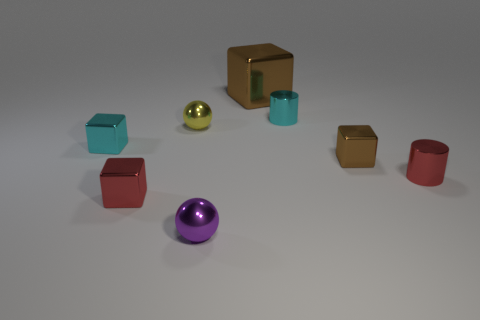Are there fewer tiny metal cubes to the left of the small cyan metal block than big purple blocks?
Provide a short and direct response. No. Does the small yellow object have the same shape as the big brown metallic thing?
Give a very brief answer. No. What is the size of the purple object that is made of the same material as the yellow ball?
Keep it short and to the point. Small. Is the number of cyan objects less than the number of small yellow balls?
Provide a succinct answer. No. What number of small things are metal objects or brown blocks?
Provide a succinct answer. 7. What number of small objects are on the left side of the big brown metallic cube and behind the purple metallic ball?
Ensure brevity in your answer.  3. Is the number of big yellow matte spheres greater than the number of brown objects?
Offer a terse response. No. What number of other things are the same shape as the tiny brown shiny thing?
Make the answer very short. 3. The block that is on the right side of the red cube and in front of the large metal object is made of what material?
Give a very brief answer. Metal. What is the size of the red block?
Give a very brief answer. Small. 